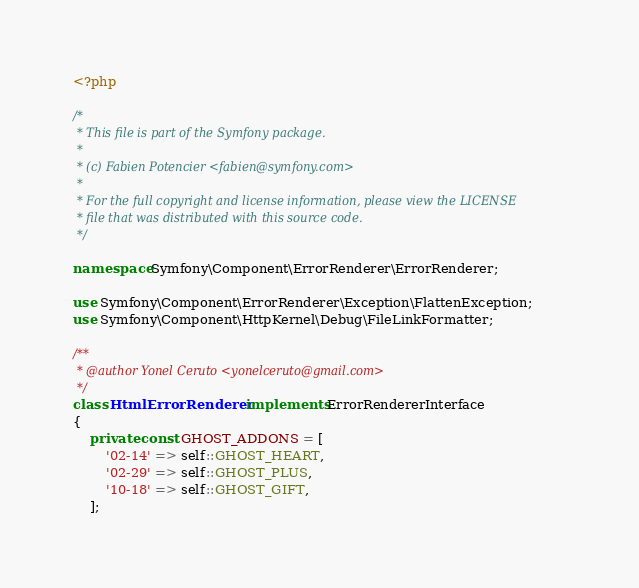<code> <loc_0><loc_0><loc_500><loc_500><_PHP_><?php

/*
 * This file is part of the Symfony package.
 *
 * (c) Fabien Potencier <fabien@symfony.com>
 *
 * For the full copyright and license information, please view the LICENSE
 * file that was distributed with this source code.
 */

namespace Symfony\Component\ErrorRenderer\ErrorRenderer;

use Symfony\Component\ErrorRenderer\Exception\FlattenException;
use Symfony\Component\HttpKernel\Debug\FileLinkFormatter;

/**
 * @author Yonel Ceruto <yonelceruto@gmail.com>
 */
class HtmlErrorRenderer implements ErrorRendererInterface
{
    private const GHOST_ADDONS = [
        '02-14' => self::GHOST_HEART,
        '02-29' => self::GHOST_PLUS,
        '10-18' => self::GHOST_GIFT,
    ];
</code> 